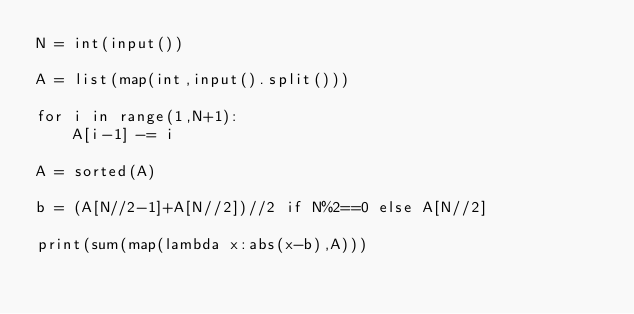Convert code to text. <code><loc_0><loc_0><loc_500><loc_500><_Python_>N = int(input())

A = list(map(int,input().split()))

for i in range(1,N+1):
    A[i-1] -= i
    
A = sorted(A)

b = (A[N//2-1]+A[N//2])//2 if N%2==0 else A[N//2]

print(sum(map(lambda x:abs(x-b),A)))</code> 